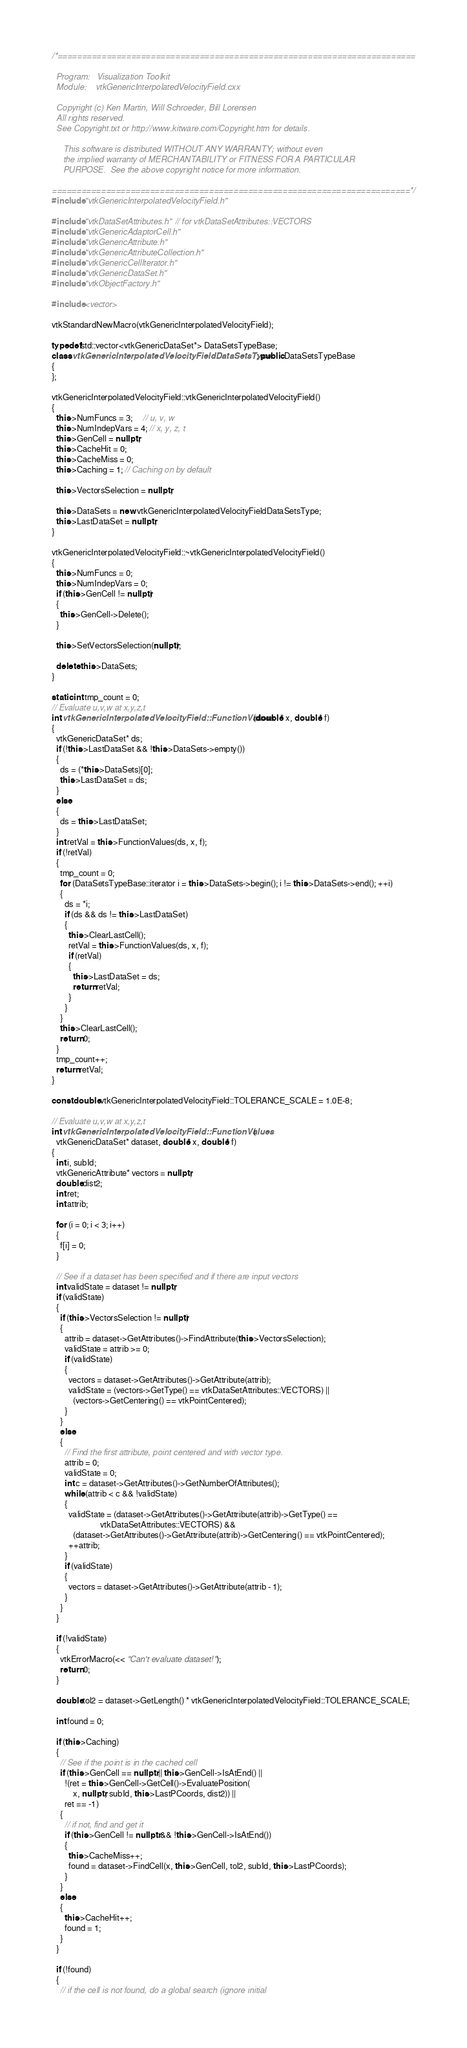<code> <loc_0><loc_0><loc_500><loc_500><_C++_>/*=========================================================================

  Program:   Visualization Toolkit
  Module:    vtkGenericInterpolatedVelocityField.cxx

  Copyright (c) Ken Martin, Will Schroeder, Bill Lorensen
  All rights reserved.
  See Copyright.txt or http://www.kitware.com/Copyright.htm for details.

     This software is distributed WITHOUT ANY WARRANTY; without even
     the implied warranty of MERCHANTABILITY or FITNESS FOR A PARTICULAR
     PURPOSE.  See the above copyright notice for more information.

=========================================================================*/
#include "vtkGenericInterpolatedVelocityField.h"

#include "vtkDataSetAttributes.h" // for vtkDataSetAttributes::VECTORS
#include "vtkGenericAdaptorCell.h"
#include "vtkGenericAttribute.h"
#include "vtkGenericAttributeCollection.h"
#include "vtkGenericCellIterator.h"
#include "vtkGenericDataSet.h"
#include "vtkObjectFactory.h"

#include <vector>

vtkStandardNewMacro(vtkGenericInterpolatedVelocityField);

typedef std::vector<vtkGenericDataSet*> DataSetsTypeBase;
class vtkGenericInterpolatedVelocityFieldDataSetsType : public DataSetsTypeBase
{
};

vtkGenericInterpolatedVelocityField::vtkGenericInterpolatedVelocityField()
{
  this->NumFuncs = 3;     // u, v, w
  this->NumIndepVars = 4; // x, y, z, t
  this->GenCell = nullptr;
  this->CacheHit = 0;
  this->CacheMiss = 0;
  this->Caching = 1; // Caching on by default

  this->VectorsSelection = nullptr;

  this->DataSets = new vtkGenericInterpolatedVelocityFieldDataSetsType;
  this->LastDataSet = nullptr;
}

vtkGenericInterpolatedVelocityField::~vtkGenericInterpolatedVelocityField()
{
  this->NumFuncs = 0;
  this->NumIndepVars = 0;
  if (this->GenCell != nullptr)
  {
    this->GenCell->Delete();
  }

  this->SetVectorsSelection(nullptr);

  delete this->DataSets;
}

static int tmp_count = 0;
// Evaluate u,v,w at x,y,z,t
int vtkGenericInterpolatedVelocityField::FunctionValues(double* x, double* f)
{
  vtkGenericDataSet* ds;
  if (!this->LastDataSet && !this->DataSets->empty())
  {
    ds = (*this->DataSets)[0];
    this->LastDataSet = ds;
  }
  else
  {
    ds = this->LastDataSet;
  }
  int retVal = this->FunctionValues(ds, x, f);
  if (!retVal)
  {
    tmp_count = 0;
    for (DataSetsTypeBase::iterator i = this->DataSets->begin(); i != this->DataSets->end(); ++i)
    {
      ds = *i;
      if (ds && ds != this->LastDataSet)
      {
        this->ClearLastCell();
        retVal = this->FunctionValues(ds, x, f);
        if (retVal)
        {
          this->LastDataSet = ds;
          return retVal;
        }
      }
    }
    this->ClearLastCell();
    return 0;
  }
  tmp_count++;
  return retVal;
}

const double vtkGenericInterpolatedVelocityField::TOLERANCE_SCALE = 1.0E-8;

// Evaluate u,v,w at x,y,z,t
int vtkGenericInterpolatedVelocityField::FunctionValues(
  vtkGenericDataSet* dataset, double* x, double* f)
{
  int i, subId;
  vtkGenericAttribute* vectors = nullptr;
  double dist2;
  int ret;
  int attrib;

  for (i = 0; i < 3; i++)
  {
    f[i] = 0;
  }

  // See if a dataset has been specified and if there are input vectors
  int validState = dataset != nullptr;
  if (validState)
  {
    if (this->VectorsSelection != nullptr)
    {
      attrib = dataset->GetAttributes()->FindAttribute(this->VectorsSelection);
      validState = attrib >= 0;
      if (validState)
      {
        vectors = dataset->GetAttributes()->GetAttribute(attrib);
        validState = (vectors->GetType() == vtkDataSetAttributes::VECTORS) ||
          (vectors->GetCentering() == vtkPointCentered);
      }
    }
    else
    {
      // Find the first attribute, point centered and with vector type.
      attrib = 0;
      validState = 0;
      int c = dataset->GetAttributes()->GetNumberOfAttributes();
      while (attrib < c && !validState)
      {
        validState = (dataset->GetAttributes()->GetAttribute(attrib)->GetType() ==
                       vtkDataSetAttributes::VECTORS) &&
          (dataset->GetAttributes()->GetAttribute(attrib)->GetCentering() == vtkPointCentered);
        ++attrib;
      }
      if (validState)
      {
        vectors = dataset->GetAttributes()->GetAttribute(attrib - 1);
      }
    }
  }

  if (!validState)
  {
    vtkErrorMacro(<< "Can't evaluate dataset!");
    return 0;
  }

  double tol2 = dataset->GetLength() * vtkGenericInterpolatedVelocityField::TOLERANCE_SCALE;

  int found = 0;

  if (this->Caching)
  {
    // See if the point is in the cached cell
    if (this->GenCell == nullptr || this->GenCell->IsAtEnd() ||
      !(ret = this->GenCell->GetCell()->EvaluatePosition(
          x, nullptr, subId, this->LastPCoords, dist2)) ||
      ret == -1)
    {
      // if not, find and get it
      if (this->GenCell != nullptr && !this->GenCell->IsAtEnd())
      {
        this->CacheMiss++;
        found = dataset->FindCell(x, this->GenCell, tol2, subId, this->LastPCoords);
      }
    }
    else
    {
      this->CacheHit++;
      found = 1;
    }
  }

  if (!found)
  {
    // if the cell is not found, do a global search (ignore initial</code> 